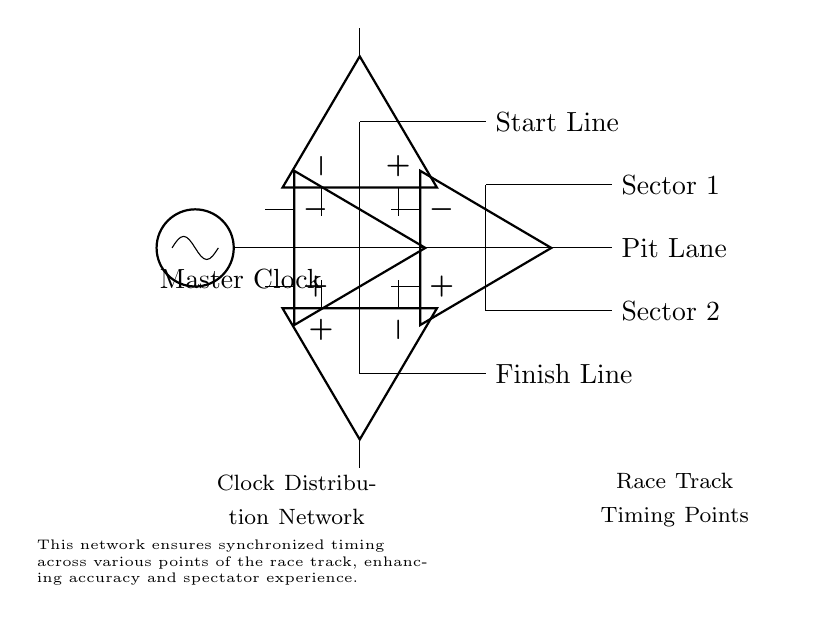What is the main component of the clock distribution network? The main component is the master clock, which serves as the primary timing source for the entire network.
Answer: Master Clock How many timing points are directly connected to the distribution network? There are five timing points connected directly to the master clock through the distribution network. These points include the start line, finish line, pit lane, and sectors 1 and 2.
Answer: Five What type of amplifiers are used in the network? The network uses operational amplifiers to buffer the clock signal, ensuring signal integrity at various distribution points.
Answer: Operational amplifiers Which timing point is the highest in position? The start line is positioned higher than the finish line and the other sector points in the circuit diagram.
Answer: Start Line What role do the buffers play in this circuit? Buffers amplify the clock signal to maintain its strength and integrity as it travels to different timing points, reducing signal degradation.
Answer: Amplification How is the clock signal distributed horizontally in the network? The clock signal is distributed horizontally through lines connecting the master clock to each timing point along with branches leading to sectors, ensuring synchronization across the race track.
Answer: Horizontally along lines 